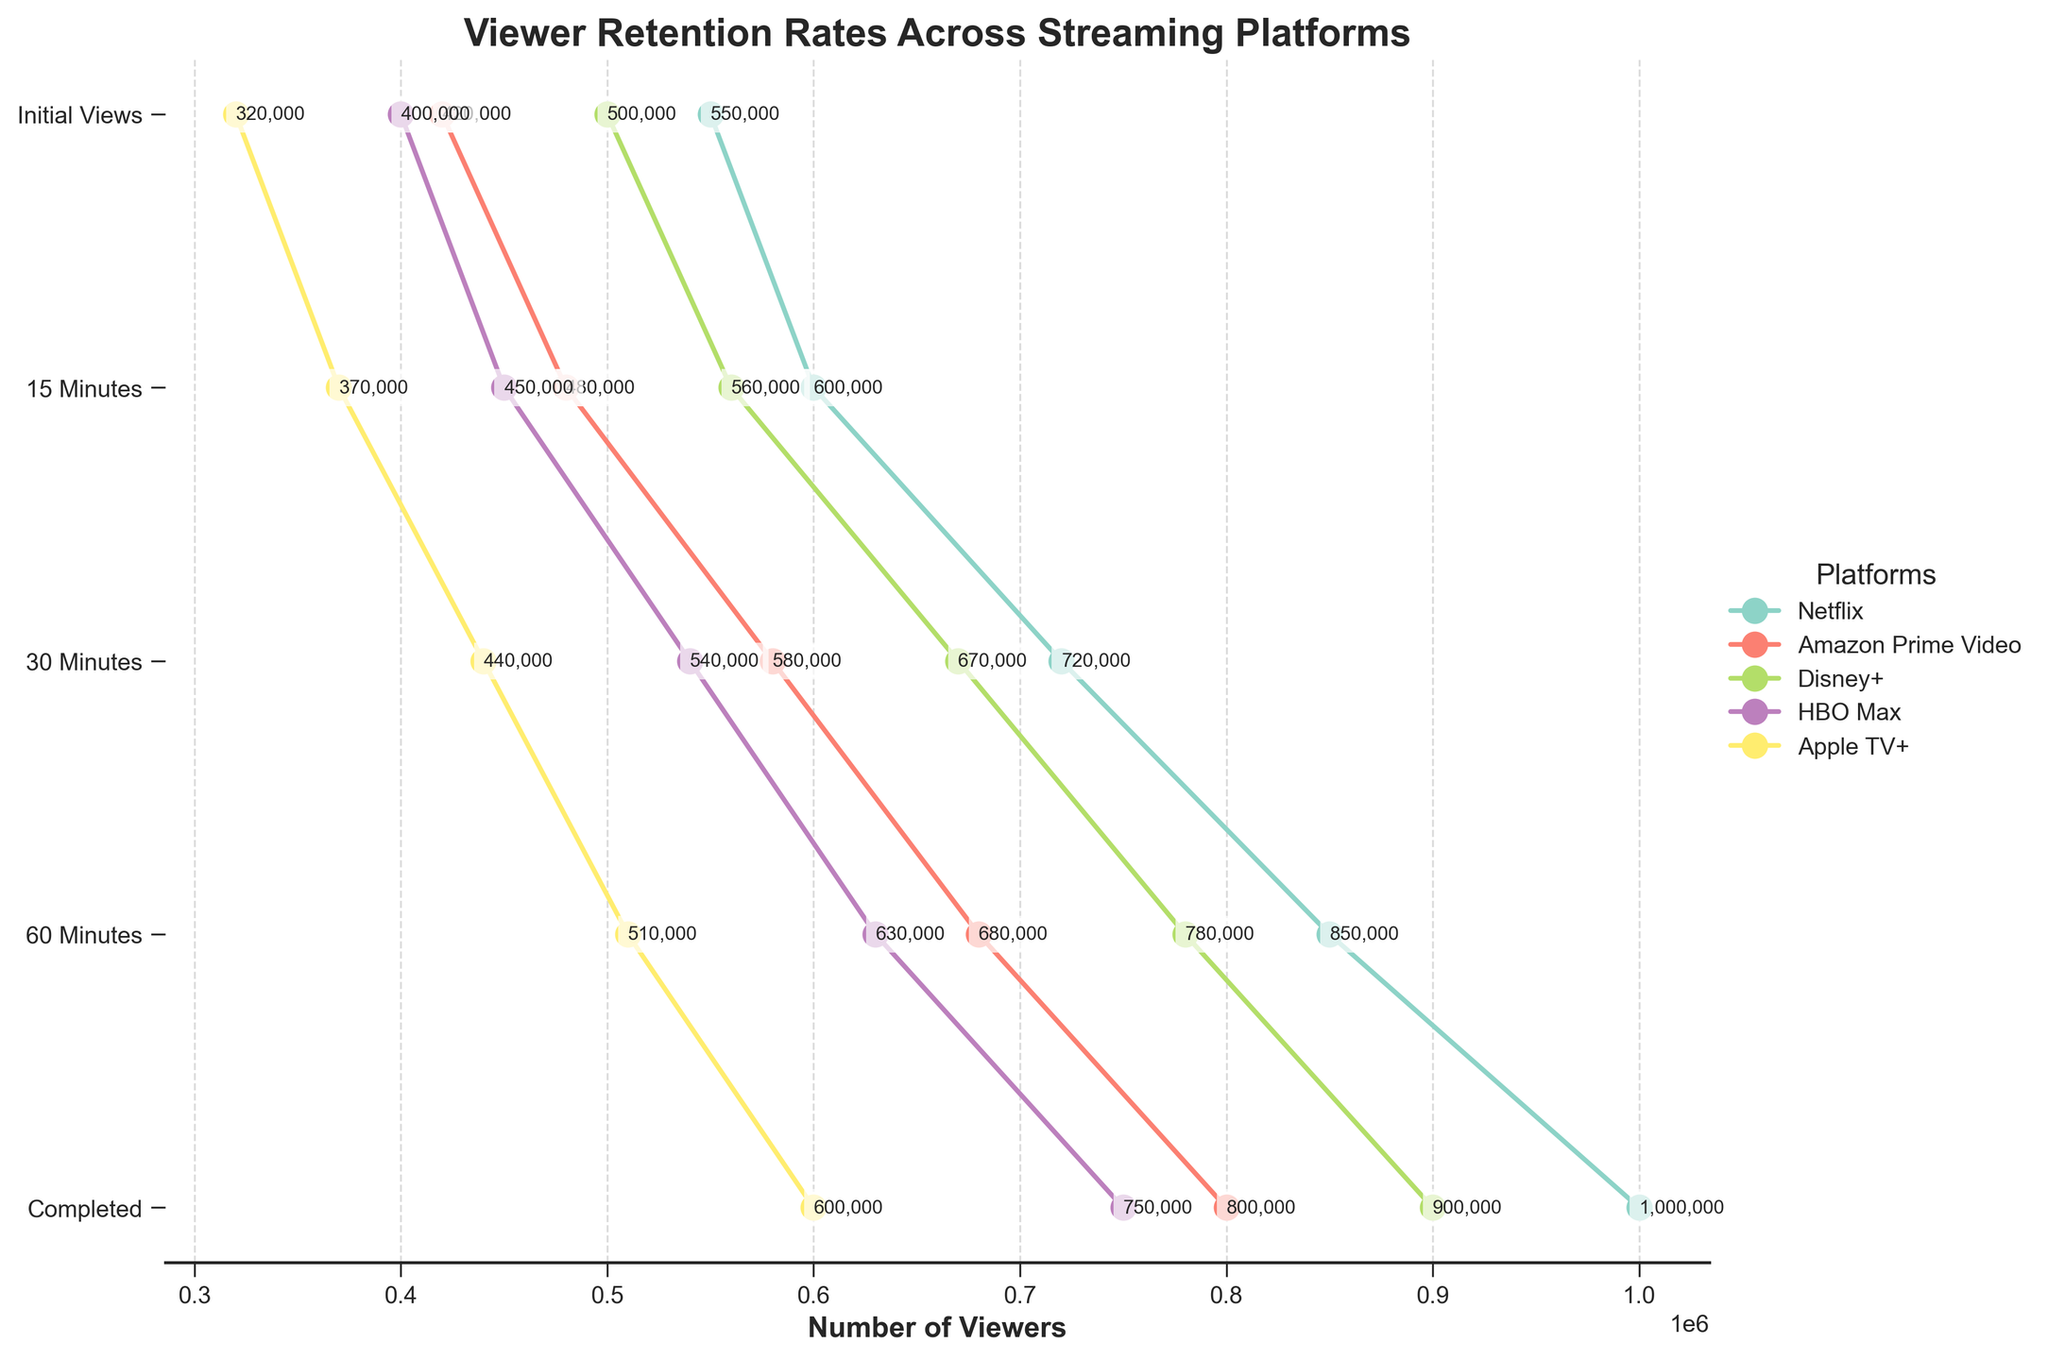What is the title of the plot? The title is usually located at the top center of the figure. It provides an overview of what the figure represents. In this case, it's "Viewer Retention Rates Across Streaming Platforms."
Answer: Viewer Retention Rates Across Streaming Platforms Which streaming platform has the highest number of initial views? Look at the "Initial Views" values on the x-axis and identify which platform has the highest number. Netflix has 1,000,000 initial views, which is the highest.
Answer: Netflix Which stage shows the largest drop in viewership for Apple TV+? Check the values for each stage from "Initial Views" to "Completed" for Apple TV+. The biggest drop is from "Initial Views" (600,000) to "15 Minutes" (510,000), which is a drop of 90,000 viewers.
Answer: From Initial Views to 15 Minutes Which platform has the highest number of viewers completing the video? Look at the "Completed" values and compare across all platforms. Netflix has 550,000 viewers completing the video, which is the highest among all platforms.
Answer: Netflix What is the average number of viewers at 60 Minutes across all platforms? Add the number of viewers at 60 Minutes for all platforms and divide by the number of platforms. (600,000 + 480,000 + 560,000 + 450,000 + 370,000) / 5 = 492,000 viewers.
Answer: 492,000 How does Disney+'s viewer retention at 60 Minutes compare to Amazon Prime Video's at the same stage? Compare the numbers for each platform at the 60 Minutes stage. Disney+ has 560,000 viewers, while Amazon Prime Video has 480,000 viewers. Disney+ has 80,000 more viewers.
Answer: Disney+ has 80,000 more viewers Which platform has the steepest decline in viewer retention from 15 to 30 Minutes? Calculate the difference between the 15 and 30 Minutes stages for each platform. Amazon Prime Video has a drop from 680,000 to 580,000, which is a decline of 100,000 viewers, the steepest among the platforms.
Answer: Amazon Prime Video What percentage of HBO Max's initial viewers completed watching the video? Divide the "Completed" value by the "Initial Views" value for HBO Max and multiply by 100. (400,000 / 750,000) * 100 = 53.3%.
Answer: 53.3% What's the difference in the number of viewers completing the video between the platform with the highest and lowest completion rates? Compare the "Completed" values for the highest (Netflix: 550,000) and lowest (Apple TV+: 320,000) to find the difference. 550,000 - 320,000 = 230,000.
Answer: 230,000 At which stage does the viewer count for Netflix first fall below 700,000? Check the stages of Netflix: Initial Views (1,000,000), 15 Minutes (850,000), 30 Minutes (720,000), 60 Minutes (600,000). The first drop below 700,000 is at the 60 Minutes stage.
Answer: 60 Minutes 